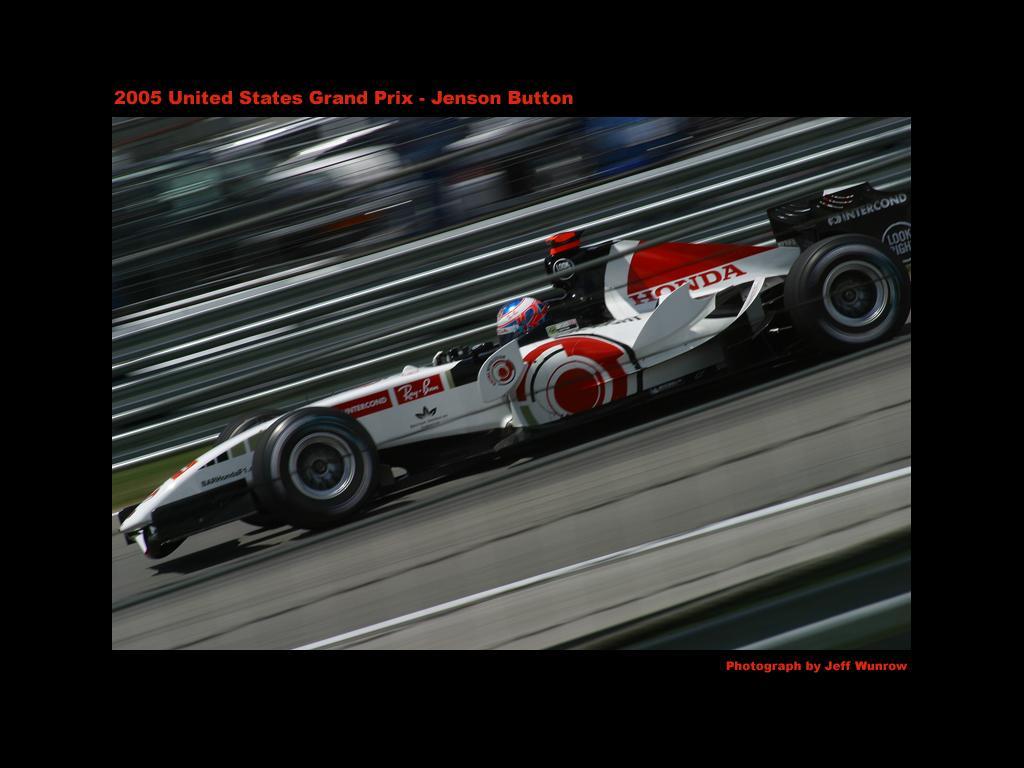How would you summarize this image in a sentence or two? In the image there is a racing car, the image is captured while the car is in motion. 